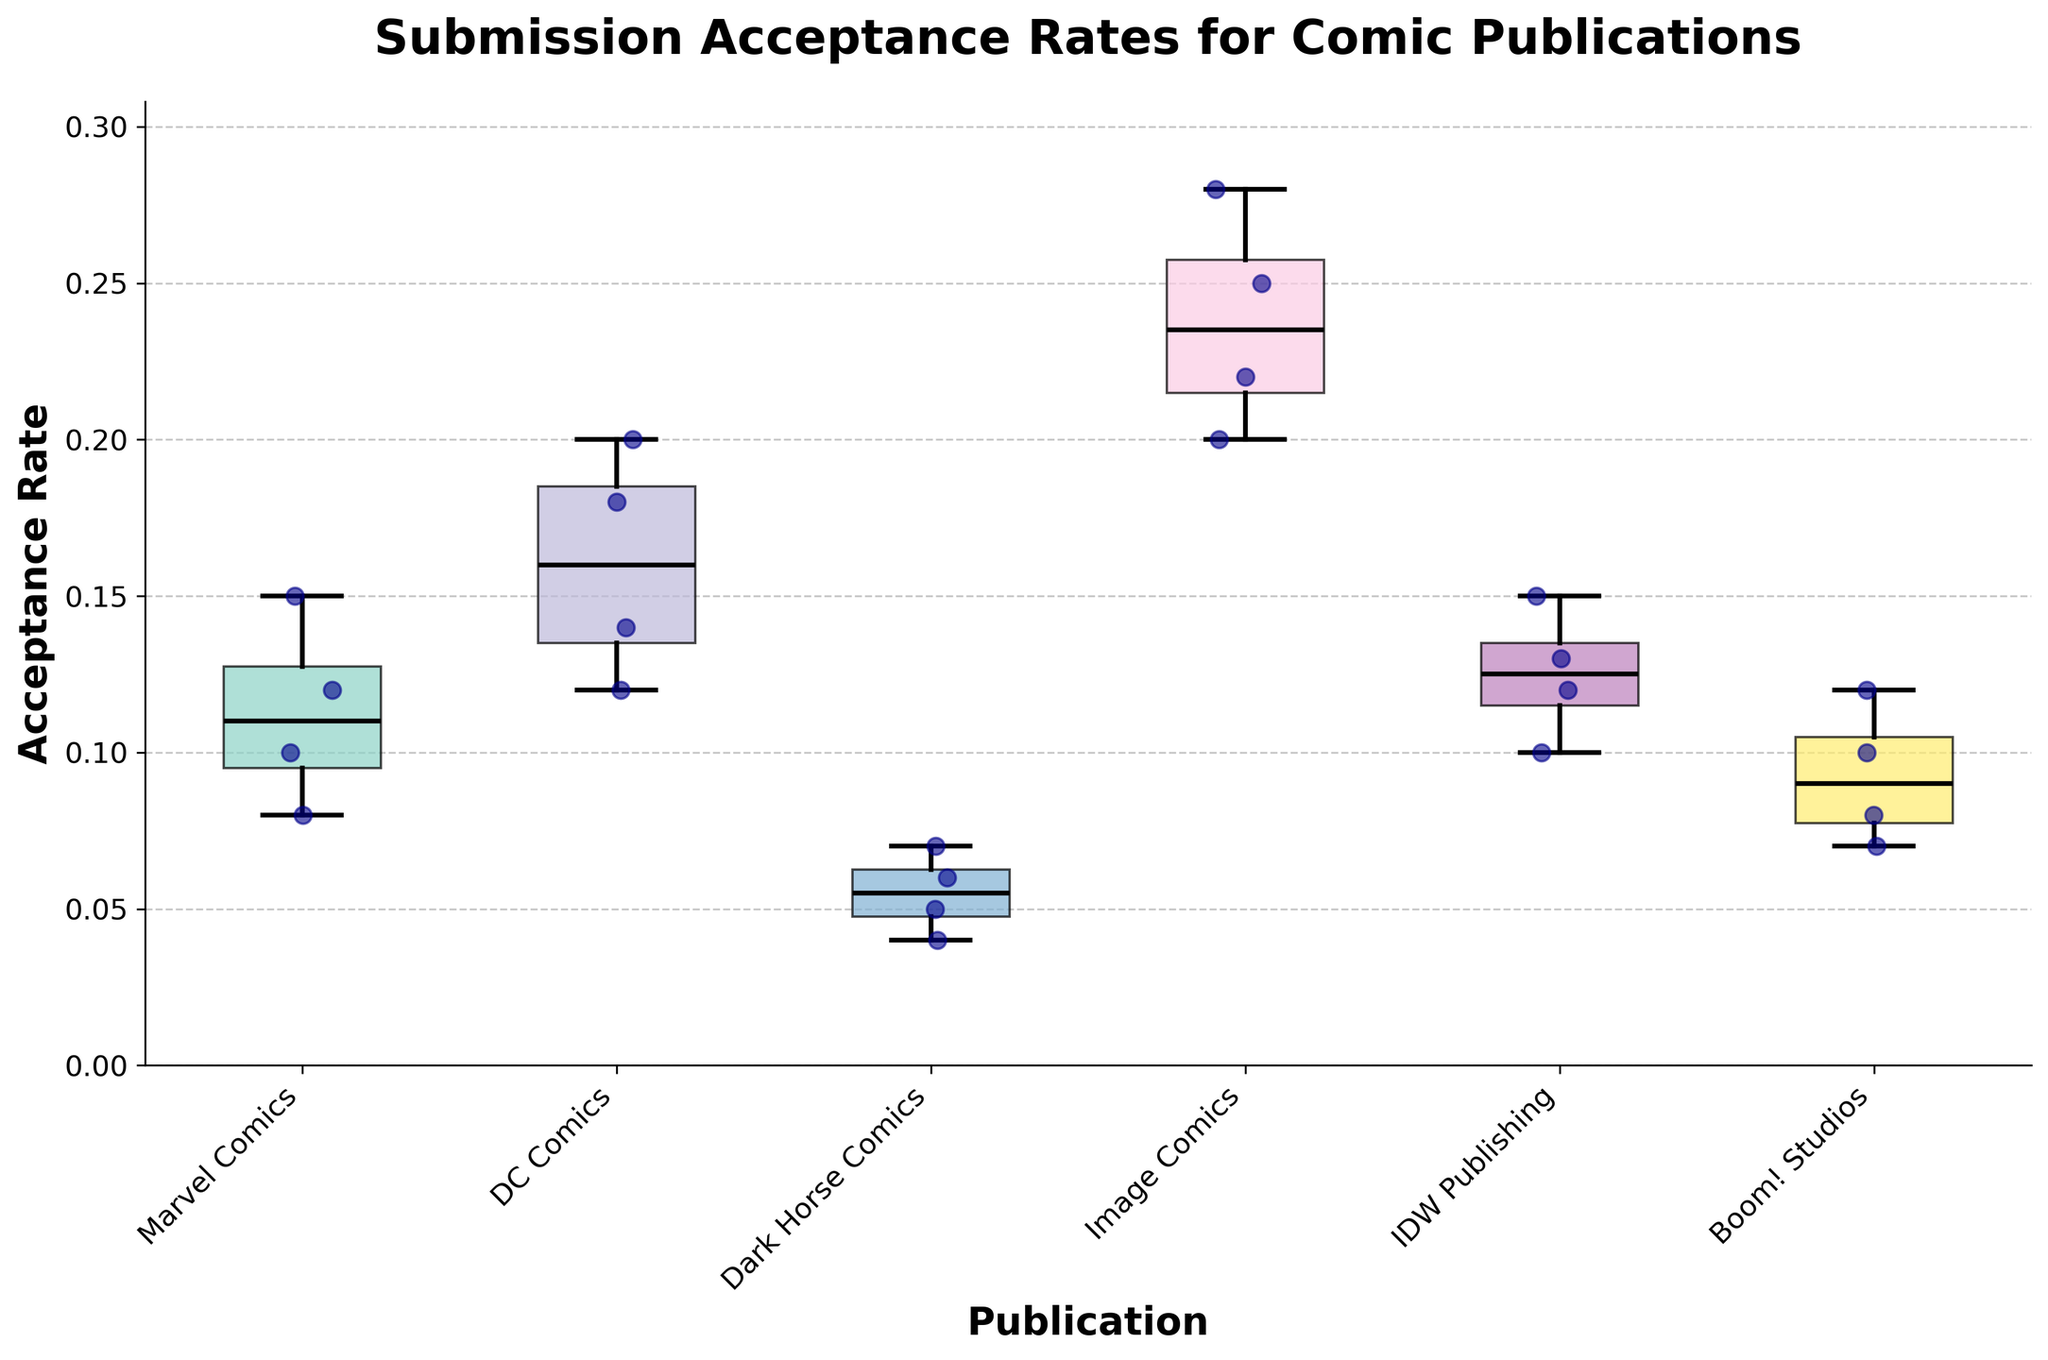What is the title of the plot? The title of the plot is typically found at the top of the chart. Here, the title is clearly labeled at the top.
Answer: Submission Acceptance Rates for Comic Publications Which publication has the highest median acceptance rate? Within a box plot, the median is represented by the horizontal line inside the box. The box corresponding to Image Comics has the highest median acceptance rate.
Answer: Image Comics What is the lowest acceptance rate observed for Dark Horse Comics? The whiskers represent the range of the data in a box plot. The lowest point of the whisker for Dark Horse Comics gives the lowest acceptance rate.
Answer: 0.04 What is the range of acceptance rates for DC Comics? The range can be found by subtracting the minimum acceptance rate from the maximum acceptance rate. For DC Comics, the range is from the lowest whisker to the highest whisker.
Answer: 0.08 (0.20 - 0.12 = 0.08) Which publication shows the most variability in its acceptance rates? The variability in a box plot is indicated by the length of its box and whiskers. The publication with the longest combined whiskers and box will show the most variability.
Answer: Image Comics Compare the median acceptance rates of Marvel Comics and Boom! Studios. Which is higher? Observing the median lines within the boxes for Marvel Comics and Boom! Studios, we can compare their positions. Marvel Comics’ median line is slightly higher than Boom! Studios’.
Answer: Marvel Comics Which publication has the smallest interquartile range (IQR) of acceptance rates? The IQR is the length of the box in the box plot, representing the middle 50% of the data. We identify the smallest box visually.
Answer: IDW Publishing How many individual acceptance rate data points are plotted for Marvel Comics? Scatter points represent individual data points. By counting the scatter points within the Marvel Comics section, we find the number of data points.
Answer: 4 What is the median acceptance rate for IDW Publishing? The median acceptance rate is represented by the horizontal line inside the box for IDW Publishing. Observing its position, it's between 0.1 and 0.15.
Answer: 0.125 (approximately) Which publication has the maximum acceptance rate, and what is that rate? The maximum acceptance rate can be identified by the highest point on the top whisker among all the box plots. This would be from Image Comics at 0.28.
Answer: Image Comics, 0.28 